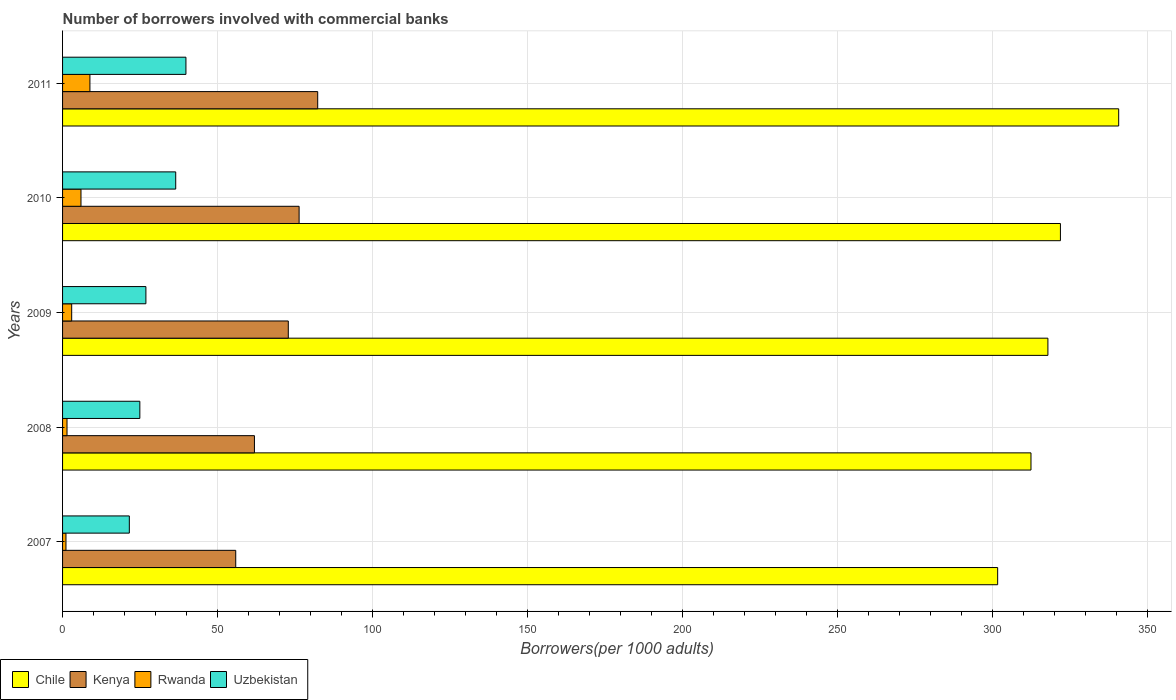How many different coloured bars are there?
Make the answer very short. 4. How many groups of bars are there?
Provide a short and direct response. 5. Are the number of bars on each tick of the Y-axis equal?
Your response must be concise. Yes. What is the number of borrowers involved with commercial banks in Chile in 2008?
Make the answer very short. 312.53. Across all years, what is the maximum number of borrowers involved with commercial banks in Uzbekistan?
Your response must be concise. 39.81. Across all years, what is the minimum number of borrowers involved with commercial banks in Uzbekistan?
Provide a succinct answer. 21.54. In which year was the number of borrowers involved with commercial banks in Kenya maximum?
Offer a terse response. 2011. What is the total number of borrowers involved with commercial banks in Uzbekistan in the graph?
Provide a succinct answer. 149.71. What is the difference between the number of borrowers involved with commercial banks in Kenya in 2010 and that in 2011?
Your answer should be compact. -6. What is the difference between the number of borrowers involved with commercial banks in Uzbekistan in 2010 and the number of borrowers involved with commercial banks in Chile in 2011?
Offer a very short reply. -304.32. What is the average number of borrowers involved with commercial banks in Rwanda per year?
Offer a very short reply. 4.05. In the year 2007, what is the difference between the number of borrowers involved with commercial banks in Kenya and number of borrowers involved with commercial banks in Chile?
Provide a short and direct response. -245.89. What is the ratio of the number of borrowers involved with commercial banks in Kenya in 2010 to that in 2011?
Provide a short and direct response. 0.93. Is the number of borrowers involved with commercial banks in Kenya in 2007 less than that in 2010?
Your answer should be compact. Yes. What is the difference between the highest and the second highest number of borrowers involved with commercial banks in Uzbekistan?
Make the answer very short. 3.3. What is the difference between the highest and the lowest number of borrowers involved with commercial banks in Chile?
Ensure brevity in your answer.  39.06. In how many years, is the number of borrowers involved with commercial banks in Uzbekistan greater than the average number of borrowers involved with commercial banks in Uzbekistan taken over all years?
Your response must be concise. 2. Is it the case that in every year, the sum of the number of borrowers involved with commercial banks in Chile and number of borrowers involved with commercial banks in Kenya is greater than the sum of number of borrowers involved with commercial banks in Uzbekistan and number of borrowers involved with commercial banks in Rwanda?
Make the answer very short. No. What does the 2nd bar from the top in 2010 represents?
Offer a very short reply. Rwanda. What does the 2nd bar from the bottom in 2009 represents?
Offer a terse response. Kenya. Is it the case that in every year, the sum of the number of borrowers involved with commercial banks in Rwanda and number of borrowers involved with commercial banks in Kenya is greater than the number of borrowers involved with commercial banks in Uzbekistan?
Give a very brief answer. Yes. How many years are there in the graph?
Make the answer very short. 5. Are the values on the major ticks of X-axis written in scientific E-notation?
Provide a short and direct response. No. Does the graph contain any zero values?
Your response must be concise. No. Does the graph contain grids?
Keep it short and to the point. Yes. Where does the legend appear in the graph?
Offer a terse response. Bottom left. How are the legend labels stacked?
Your answer should be very brief. Horizontal. What is the title of the graph?
Provide a succinct answer. Number of borrowers involved with commercial banks. Does "Mali" appear as one of the legend labels in the graph?
Your answer should be compact. No. What is the label or title of the X-axis?
Your response must be concise. Borrowers(per 1000 adults). What is the label or title of the Y-axis?
Ensure brevity in your answer.  Years. What is the Borrowers(per 1000 adults) in Chile in 2007?
Make the answer very short. 301.77. What is the Borrowers(per 1000 adults) of Kenya in 2007?
Ensure brevity in your answer.  55.89. What is the Borrowers(per 1000 adults) in Rwanda in 2007?
Keep it short and to the point. 1.1. What is the Borrowers(per 1000 adults) of Uzbekistan in 2007?
Your response must be concise. 21.54. What is the Borrowers(per 1000 adults) of Chile in 2008?
Give a very brief answer. 312.53. What is the Borrowers(per 1000 adults) of Kenya in 2008?
Your answer should be compact. 61.92. What is the Borrowers(per 1000 adults) in Rwanda in 2008?
Provide a succinct answer. 1.44. What is the Borrowers(per 1000 adults) in Uzbekistan in 2008?
Your response must be concise. 24.94. What is the Borrowers(per 1000 adults) of Chile in 2009?
Your answer should be compact. 317.99. What is the Borrowers(per 1000 adults) in Kenya in 2009?
Offer a very short reply. 72.85. What is the Borrowers(per 1000 adults) of Rwanda in 2009?
Make the answer very short. 2.94. What is the Borrowers(per 1000 adults) of Uzbekistan in 2009?
Keep it short and to the point. 26.9. What is the Borrowers(per 1000 adults) of Chile in 2010?
Give a very brief answer. 322.03. What is the Borrowers(per 1000 adults) of Kenya in 2010?
Provide a succinct answer. 76.34. What is the Borrowers(per 1000 adults) in Rwanda in 2010?
Offer a terse response. 5.94. What is the Borrowers(per 1000 adults) of Uzbekistan in 2010?
Your answer should be compact. 36.52. What is the Borrowers(per 1000 adults) in Chile in 2011?
Provide a succinct answer. 340.83. What is the Borrowers(per 1000 adults) in Kenya in 2011?
Your response must be concise. 82.34. What is the Borrowers(per 1000 adults) in Rwanda in 2011?
Provide a succinct answer. 8.83. What is the Borrowers(per 1000 adults) of Uzbekistan in 2011?
Provide a succinct answer. 39.81. Across all years, what is the maximum Borrowers(per 1000 adults) in Chile?
Offer a very short reply. 340.83. Across all years, what is the maximum Borrowers(per 1000 adults) in Kenya?
Your answer should be very brief. 82.34. Across all years, what is the maximum Borrowers(per 1000 adults) of Rwanda?
Provide a succinct answer. 8.83. Across all years, what is the maximum Borrowers(per 1000 adults) in Uzbekistan?
Your answer should be compact. 39.81. Across all years, what is the minimum Borrowers(per 1000 adults) in Chile?
Provide a succinct answer. 301.77. Across all years, what is the minimum Borrowers(per 1000 adults) of Kenya?
Make the answer very short. 55.89. Across all years, what is the minimum Borrowers(per 1000 adults) of Rwanda?
Your answer should be very brief. 1.1. Across all years, what is the minimum Borrowers(per 1000 adults) of Uzbekistan?
Make the answer very short. 21.54. What is the total Borrowers(per 1000 adults) in Chile in the graph?
Provide a short and direct response. 1595.16. What is the total Borrowers(per 1000 adults) in Kenya in the graph?
Offer a terse response. 349.34. What is the total Borrowers(per 1000 adults) of Rwanda in the graph?
Make the answer very short. 20.25. What is the total Borrowers(per 1000 adults) of Uzbekistan in the graph?
Your answer should be very brief. 149.71. What is the difference between the Borrowers(per 1000 adults) of Chile in 2007 and that in 2008?
Your answer should be compact. -10.76. What is the difference between the Borrowers(per 1000 adults) of Kenya in 2007 and that in 2008?
Keep it short and to the point. -6.04. What is the difference between the Borrowers(per 1000 adults) in Rwanda in 2007 and that in 2008?
Offer a very short reply. -0.34. What is the difference between the Borrowers(per 1000 adults) of Uzbekistan in 2007 and that in 2008?
Ensure brevity in your answer.  -3.4. What is the difference between the Borrowers(per 1000 adults) of Chile in 2007 and that in 2009?
Make the answer very short. -16.22. What is the difference between the Borrowers(per 1000 adults) of Kenya in 2007 and that in 2009?
Your answer should be compact. -16.96. What is the difference between the Borrowers(per 1000 adults) in Rwanda in 2007 and that in 2009?
Keep it short and to the point. -1.85. What is the difference between the Borrowers(per 1000 adults) of Uzbekistan in 2007 and that in 2009?
Offer a very short reply. -5.35. What is the difference between the Borrowers(per 1000 adults) in Chile in 2007 and that in 2010?
Your response must be concise. -20.26. What is the difference between the Borrowers(per 1000 adults) in Kenya in 2007 and that in 2010?
Your answer should be compact. -20.45. What is the difference between the Borrowers(per 1000 adults) of Rwanda in 2007 and that in 2010?
Your response must be concise. -4.85. What is the difference between the Borrowers(per 1000 adults) in Uzbekistan in 2007 and that in 2010?
Keep it short and to the point. -14.97. What is the difference between the Borrowers(per 1000 adults) of Chile in 2007 and that in 2011?
Make the answer very short. -39.06. What is the difference between the Borrowers(per 1000 adults) in Kenya in 2007 and that in 2011?
Your response must be concise. -26.45. What is the difference between the Borrowers(per 1000 adults) of Rwanda in 2007 and that in 2011?
Give a very brief answer. -7.73. What is the difference between the Borrowers(per 1000 adults) in Uzbekistan in 2007 and that in 2011?
Keep it short and to the point. -18.27. What is the difference between the Borrowers(per 1000 adults) in Chile in 2008 and that in 2009?
Your answer should be very brief. -5.46. What is the difference between the Borrowers(per 1000 adults) of Kenya in 2008 and that in 2009?
Make the answer very short. -10.93. What is the difference between the Borrowers(per 1000 adults) in Rwanda in 2008 and that in 2009?
Your response must be concise. -1.51. What is the difference between the Borrowers(per 1000 adults) of Uzbekistan in 2008 and that in 2009?
Your response must be concise. -1.96. What is the difference between the Borrowers(per 1000 adults) of Chile in 2008 and that in 2010?
Keep it short and to the point. -9.5. What is the difference between the Borrowers(per 1000 adults) of Kenya in 2008 and that in 2010?
Provide a short and direct response. -14.42. What is the difference between the Borrowers(per 1000 adults) of Rwanda in 2008 and that in 2010?
Ensure brevity in your answer.  -4.51. What is the difference between the Borrowers(per 1000 adults) in Uzbekistan in 2008 and that in 2010?
Provide a short and direct response. -11.57. What is the difference between the Borrowers(per 1000 adults) of Chile in 2008 and that in 2011?
Offer a very short reply. -28.3. What is the difference between the Borrowers(per 1000 adults) of Kenya in 2008 and that in 2011?
Your response must be concise. -20.41. What is the difference between the Borrowers(per 1000 adults) in Rwanda in 2008 and that in 2011?
Provide a succinct answer. -7.39. What is the difference between the Borrowers(per 1000 adults) of Uzbekistan in 2008 and that in 2011?
Offer a very short reply. -14.87. What is the difference between the Borrowers(per 1000 adults) of Chile in 2009 and that in 2010?
Offer a very short reply. -4.04. What is the difference between the Borrowers(per 1000 adults) of Kenya in 2009 and that in 2010?
Offer a terse response. -3.49. What is the difference between the Borrowers(per 1000 adults) in Rwanda in 2009 and that in 2010?
Your answer should be compact. -3. What is the difference between the Borrowers(per 1000 adults) in Uzbekistan in 2009 and that in 2010?
Your answer should be very brief. -9.62. What is the difference between the Borrowers(per 1000 adults) of Chile in 2009 and that in 2011?
Provide a succinct answer. -22.84. What is the difference between the Borrowers(per 1000 adults) of Kenya in 2009 and that in 2011?
Your answer should be compact. -9.49. What is the difference between the Borrowers(per 1000 adults) in Rwanda in 2009 and that in 2011?
Provide a succinct answer. -5.89. What is the difference between the Borrowers(per 1000 adults) of Uzbekistan in 2009 and that in 2011?
Provide a short and direct response. -12.92. What is the difference between the Borrowers(per 1000 adults) in Chile in 2010 and that in 2011?
Your answer should be compact. -18.8. What is the difference between the Borrowers(per 1000 adults) of Kenya in 2010 and that in 2011?
Give a very brief answer. -6. What is the difference between the Borrowers(per 1000 adults) in Rwanda in 2010 and that in 2011?
Provide a short and direct response. -2.89. What is the difference between the Borrowers(per 1000 adults) of Uzbekistan in 2010 and that in 2011?
Offer a terse response. -3.3. What is the difference between the Borrowers(per 1000 adults) of Chile in 2007 and the Borrowers(per 1000 adults) of Kenya in 2008?
Give a very brief answer. 239.85. What is the difference between the Borrowers(per 1000 adults) in Chile in 2007 and the Borrowers(per 1000 adults) in Rwanda in 2008?
Give a very brief answer. 300.34. What is the difference between the Borrowers(per 1000 adults) in Chile in 2007 and the Borrowers(per 1000 adults) in Uzbekistan in 2008?
Your answer should be very brief. 276.83. What is the difference between the Borrowers(per 1000 adults) of Kenya in 2007 and the Borrowers(per 1000 adults) of Rwanda in 2008?
Provide a succinct answer. 54.45. What is the difference between the Borrowers(per 1000 adults) in Kenya in 2007 and the Borrowers(per 1000 adults) in Uzbekistan in 2008?
Make the answer very short. 30.95. What is the difference between the Borrowers(per 1000 adults) in Rwanda in 2007 and the Borrowers(per 1000 adults) in Uzbekistan in 2008?
Provide a succinct answer. -23.84. What is the difference between the Borrowers(per 1000 adults) in Chile in 2007 and the Borrowers(per 1000 adults) in Kenya in 2009?
Offer a very short reply. 228.92. What is the difference between the Borrowers(per 1000 adults) of Chile in 2007 and the Borrowers(per 1000 adults) of Rwanda in 2009?
Offer a terse response. 298.83. What is the difference between the Borrowers(per 1000 adults) of Chile in 2007 and the Borrowers(per 1000 adults) of Uzbekistan in 2009?
Offer a terse response. 274.88. What is the difference between the Borrowers(per 1000 adults) of Kenya in 2007 and the Borrowers(per 1000 adults) of Rwanda in 2009?
Your answer should be compact. 52.94. What is the difference between the Borrowers(per 1000 adults) in Kenya in 2007 and the Borrowers(per 1000 adults) in Uzbekistan in 2009?
Provide a short and direct response. 28.99. What is the difference between the Borrowers(per 1000 adults) of Rwanda in 2007 and the Borrowers(per 1000 adults) of Uzbekistan in 2009?
Offer a very short reply. -25.8. What is the difference between the Borrowers(per 1000 adults) in Chile in 2007 and the Borrowers(per 1000 adults) in Kenya in 2010?
Provide a succinct answer. 225.43. What is the difference between the Borrowers(per 1000 adults) of Chile in 2007 and the Borrowers(per 1000 adults) of Rwanda in 2010?
Your answer should be very brief. 295.83. What is the difference between the Borrowers(per 1000 adults) in Chile in 2007 and the Borrowers(per 1000 adults) in Uzbekistan in 2010?
Your answer should be very brief. 265.26. What is the difference between the Borrowers(per 1000 adults) of Kenya in 2007 and the Borrowers(per 1000 adults) of Rwanda in 2010?
Offer a terse response. 49.94. What is the difference between the Borrowers(per 1000 adults) of Kenya in 2007 and the Borrowers(per 1000 adults) of Uzbekistan in 2010?
Offer a terse response. 19.37. What is the difference between the Borrowers(per 1000 adults) in Rwanda in 2007 and the Borrowers(per 1000 adults) in Uzbekistan in 2010?
Give a very brief answer. -35.42. What is the difference between the Borrowers(per 1000 adults) in Chile in 2007 and the Borrowers(per 1000 adults) in Kenya in 2011?
Offer a terse response. 219.43. What is the difference between the Borrowers(per 1000 adults) in Chile in 2007 and the Borrowers(per 1000 adults) in Rwanda in 2011?
Keep it short and to the point. 292.94. What is the difference between the Borrowers(per 1000 adults) in Chile in 2007 and the Borrowers(per 1000 adults) in Uzbekistan in 2011?
Give a very brief answer. 261.96. What is the difference between the Borrowers(per 1000 adults) of Kenya in 2007 and the Borrowers(per 1000 adults) of Rwanda in 2011?
Your answer should be very brief. 47.06. What is the difference between the Borrowers(per 1000 adults) in Kenya in 2007 and the Borrowers(per 1000 adults) in Uzbekistan in 2011?
Offer a terse response. 16.07. What is the difference between the Borrowers(per 1000 adults) in Rwanda in 2007 and the Borrowers(per 1000 adults) in Uzbekistan in 2011?
Your response must be concise. -38.72. What is the difference between the Borrowers(per 1000 adults) of Chile in 2008 and the Borrowers(per 1000 adults) of Kenya in 2009?
Give a very brief answer. 239.68. What is the difference between the Borrowers(per 1000 adults) of Chile in 2008 and the Borrowers(per 1000 adults) of Rwanda in 2009?
Offer a very short reply. 309.59. What is the difference between the Borrowers(per 1000 adults) in Chile in 2008 and the Borrowers(per 1000 adults) in Uzbekistan in 2009?
Provide a succinct answer. 285.64. What is the difference between the Borrowers(per 1000 adults) of Kenya in 2008 and the Borrowers(per 1000 adults) of Rwanda in 2009?
Offer a terse response. 58.98. What is the difference between the Borrowers(per 1000 adults) in Kenya in 2008 and the Borrowers(per 1000 adults) in Uzbekistan in 2009?
Offer a terse response. 35.03. What is the difference between the Borrowers(per 1000 adults) of Rwanda in 2008 and the Borrowers(per 1000 adults) of Uzbekistan in 2009?
Your answer should be very brief. -25.46. What is the difference between the Borrowers(per 1000 adults) in Chile in 2008 and the Borrowers(per 1000 adults) in Kenya in 2010?
Your answer should be very brief. 236.19. What is the difference between the Borrowers(per 1000 adults) of Chile in 2008 and the Borrowers(per 1000 adults) of Rwanda in 2010?
Ensure brevity in your answer.  306.59. What is the difference between the Borrowers(per 1000 adults) of Chile in 2008 and the Borrowers(per 1000 adults) of Uzbekistan in 2010?
Provide a short and direct response. 276.02. What is the difference between the Borrowers(per 1000 adults) of Kenya in 2008 and the Borrowers(per 1000 adults) of Rwanda in 2010?
Provide a short and direct response. 55.98. What is the difference between the Borrowers(per 1000 adults) in Kenya in 2008 and the Borrowers(per 1000 adults) in Uzbekistan in 2010?
Provide a succinct answer. 25.41. What is the difference between the Borrowers(per 1000 adults) of Rwanda in 2008 and the Borrowers(per 1000 adults) of Uzbekistan in 2010?
Keep it short and to the point. -35.08. What is the difference between the Borrowers(per 1000 adults) of Chile in 2008 and the Borrowers(per 1000 adults) of Kenya in 2011?
Offer a very short reply. 230.19. What is the difference between the Borrowers(per 1000 adults) of Chile in 2008 and the Borrowers(per 1000 adults) of Rwanda in 2011?
Your response must be concise. 303.7. What is the difference between the Borrowers(per 1000 adults) of Chile in 2008 and the Borrowers(per 1000 adults) of Uzbekistan in 2011?
Provide a short and direct response. 272.72. What is the difference between the Borrowers(per 1000 adults) of Kenya in 2008 and the Borrowers(per 1000 adults) of Rwanda in 2011?
Provide a short and direct response. 53.09. What is the difference between the Borrowers(per 1000 adults) in Kenya in 2008 and the Borrowers(per 1000 adults) in Uzbekistan in 2011?
Your answer should be compact. 22.11. What is the difference between the Borrowers(per 1000 adults) of Rwanda in 2008 and the Borrowers(per 1000 adults) of Uzbekistan in 2011?
Offer a very short reply. -38.38. What is the difference between the Borrowers(per 1000 adults) of Chile in 2009 and the Borrowers(per 1000 adults) of Kenya in 2010?
Your answer should be very brief. 241.65. What is the difference between the Borrowers(per 1000 adults) in Chile in 2009 and the Borrowers(per 1000 adults) in Rwanda in 2010?
Make the answer very short. 312.05. What is the difference between the Borrowers(per 1000 adults) in Chile in 2009 and the Borrowers(per 1000 adults) in Uzbekistan in 2010?
Give a very brief answer. 281.48. What is the difference between the Borrowers(per 1000 adults) in Kenya in 2009 and the Borrowers(per 1000 adults) in Rwanda in 2010?
Provide a short and direct response. 66.9. What is the difference between the Borrowers(per 1000 adults) in Kenya in 2009 and the Borrowers(per 1000 adults) in Uzbekistan in 2010?
Offer a terse response. 36.33. What is the difference between the Borrowers(per 1000 adults) in Rwanda in 2009 and the Borrowers(per 1000 adults) in Uzbekistan in 2010?
Provide a succinct answer. -33.57. What is the difference between the Borrowers(per 1000 adults) in Chile in 2009 and the Borrowers(per 1000 adults) in Kenya in 2011?
Your answer should be compact. 235.65. What is the difference between the Borrowers(per 1000 adults) in Chile in 2009 and the Borrowers(per 1000 adults) in Rwanda in 2011?
Provide a short and direct response. 309.16. What is the difference between the Borrowers(per 1000 adults) in Chile in 2009 and the Borrowers(per 1000 adults) in Uzbekistan in 2011?
Keep it short and to the point. 278.18. What is the difference between the Borrowers(per 1000 adults) of Kenya in 2009 and the Borrowers(per 1000 adults) of Rwanda in 2011?
Provide a short and direct response. 64.02. What is the difference between the Borrowers(per 1000 adults) in Kenya in 2009 and the Borrowers(per 1000 adults) in Uzbekistan in 2011?
Make the answer very short. 33.03. What is the difference between the Borrowers(per 1000 adults) in Rwanda in 2009 and the Borrowers(per 1000 adults) in Uzbekistan in 2011?
Ensure brevity in your answer.  -36.87. What is the difference between the Borrowers(per 1000 adults) of Chile in 2010 and the Borrowers(per 1000 adults) of Kenya in 2011?
Make the answer very short. 239.69. What is the difference between the Borrowers(per 1000 adults) in Chile in 2010 and the Borrowers(per 1000 adults) in Rwanda in 2011?
Ensure brevity in your answer.  313.2. What is the difference between the Borrowers(per 1000 adults) in Chile in 2010 and the Borrowers(per 1000 adults) in Uzbekistan in 2011?
Your response must be concise. 282.22. What is the difference between the Borrowers(per 1000 adults) in Kenya in 2010 and the Borrowers(per 1000 adults) in Rwanda in 2011?
Provide a succinct answer. 67.51. What is the difference between the Borrowers(per 1000 adults) of Kenya in 2010 and the Borrowers(per 1000 adults) of Uzbekistan in 2011?
Offer a very short reply. 36.53. What is the difference between the Borrowers(per 1000 adults) of Rwanda in 2010 and the Borrowers(per 1000 adults) of Uzbekistan in 2011?
Provide a short and direct response. -33.87. What is the average Borrowers(per 1000 adults) of Chile per year?
Your response must be concise. 319.03. What is the average Borrowers(per 1000 adults) of Kenya per year?
Your response must be concise. 69.87. What is the average Borrowers(per 1000 adults) in Rwanda per year?
Your answer should be compact. 4.05. What is the average Borrowers(per 1000 adults) in Uzbekistan per year?
Give a very brief answer. 29.94. In the year 2007, what is the difference between the Borrowers(per 1000 adults) of Chile and Borrowers(per 1000 adults) of Kenya?
Your answer should be very brief. 245.89. In the year 2007, what is the difference between the Borrowers(per 1000 adults) in Chile and Borrowers(per 1000 adults) in Rwanda?
Your answer should be compact. 300.68. In the year 2007, what is the difference between the Borrowers(per 1000 adults) of Chile and Borrowers(per 1000 adults) of Uzbekistan?
Give a very brief answer. 280.23. In the year 2007, what is the difference between the Borrowers(per 1000 adults) in Kenya and Borrowers(per 1000 adults) in Rwanda?
Provide a short and direct response. 54.79. In the year 2007, what is the difference between the Borrowers(per 1000 adults) in Kenya and Borrowers(per 1000 adults) in Uzbekistan?
Your response must be concise. 34.34. In the year 2007, what is the difference between the Borrowers(per 1000 adults) of Rwanda and Borrowers(per 1000 adults) of Uzbekistan?
Offer a very short reply. -20.45. In the year 2008, what is the difference between the Borrowers(per 1000 adults) of Chile and Borrowers(per 1000 adults) of Kenya?
Provide a short and direct response. 250.61. In the year 2008, what is the difference between the Borrowers(per 1000 adults) of Chile and Borrowers(per 1000 adults) of Rwanda?
Your answer should be very brief. 311.1. In the year 2008, what is the difference between the Borrowers(per 1000 adults) in Chile and Borrowers(per 1000 adults) in Uzbekistan?
Provide a succinct answer. 287.59. In the year 2008, what is the difference between the Borrowers(per 1000 adults) in Kenya and Borrowers(per 1000 adults) in Rwanda?
Provide a short and direct response. 60.49. In the year 2008, what is the difference between the Borrowers(per 1000 adults) of Kenya and Borrowers(per 1000 adults) of Uzbekistan?
Make the answer very short. 36.98. In the year 2008, what is the difference between the Borrowers(per 1000 adults) in Rwanda and Borrowers(per 1000 adults) in Uzbekistan?
Your response must be concise. -23.51. In the year 2009, what is the difference between the Borrowers(per 1000 adults) in Chile and Borrowers(per 1000 adults) in Kenya?
Give a very brief answer. 245.14. In the year 2009, what is the difference between the Borrowers(per 1000 adults) in Chile and Borrowers(per 1000 adults) in Rwanda?
Your answer should be compact. 315.05. In the year 2009, what is the difference between the Borrowers(per 1000 adults) of Chile and Borrowers(per 1000 adults) of Uzbekistan?
Provide a short and direct response. 291.09. In the year 2009, what is the difference between the Borrowers(per 1000 adults) of Kenya and Borrowers(per 1000 adults) of Rwanda?
Give a very brief answer. 69.9. In the year 2009, what is the difference between the Borrowers(per 1000 adults) in Kenya and Borrowers(per 1000 adults) in Uzbekistan?
Keep it short and to the point. 45.95. In the year 2009, what is the difference between the Borrowers(per 1000 adults) in Rwanda and Borrowers(per 1000 adults) in Uzbekistan?
Make the answer very short. -23.95. In the year 2010, what is the difference between the Borrowers(per 1000 adults) in Chile and Borrowers(per 1000 adults) in Kenya?
Your answer should be very brief. 245.69. In the year 2010, what is the difference between the Borrowers(per 1000 adults) of Chile and Borrowers(per 1000 adults) of Rwanda?
Make the answer very short. 316.09. In the year 2010, what is the difference between the Borrowers(per 1000 adults) in Chile and Borrowers(per 1000 adults) in Uzbekistan?
Offer a terse response. 285.52. In the year 2010, what is the difference between the Borrowers(per 1000 adults) in Kenya and Borrowers(per 1000 adults) in Rwanda?
Your answer should be compact. 70.4. In the year 2010, what is the difference between the Borrowers(per 1000 adults) of Kenya and Borrowers(per 1000 adults) of Uzbekistan?
Offer a terse response. 39.82. In the year 2010, what is the difference between the Borrowers(per 1000 adults) in Rwanda and Borrowers(per 1000 adults) in Uzbekistan?
Provide a succinct answer. -30.57. In the year 2011, what is the difference between the Borrowers(per 1000 adults) of Chile and Borrowers(per 1000 adults) of Kenya?
Offer a very short reply. 258.5. In the year 2011, what is the difference between the Borrowers(per 1000 adults) in Chile and Borrowers(per 1000 adults) in Rwanda?
Ensure brevity in your answer.  332. In the year 2011, what is the difference between the Borrowers(per 1000 adults) in Chile and Borrowers(per 1000 adults) in Uzbekistan?
Your answer should be compact. 301.02. In the year 2011, what is the difference between the Borrowers(per 1000 adults) of Kenya and Borrowers(per 1000 adults) of Rwanda?
Make the answer very short. 73.51. In the year 2011, what is the difference between the Borrowers(per 1000 adults) of Kenya and Borrowers(per 1000 adults) of Uzbekistan?
Keep it short and to the point. 42.52. In the year 2011, what is the difference between the Borrowers(per 1000 adults) in Rwanda and Borrowers(per 1000 adults) in Uzbekistan?
Give a very brief answer. -30.98. What is the ratio of the Borrowers(per 1000 adults) in Chile in 2007 to that in 2008?
Make the answer very short. 0.97. What is the ratio of the Borrowers(per 1000 adults) of Kenya in 2007 to that in 2008?
Your answer should be very brief. 0.9. What is the ratio of the Borrowers(per 1000 adults) in Rwanda in 2007 to that in 2008?
Your response must be concise. 0.76. What is the ratio of the Borrowers(per 1000 adults) of Uzbekistan in 2007 to that in 2008?
Your response must be concise. 0.86. What is the ratio of the Borrowers(per 1000 adults) in Chile in 2007 to that in 2009?
Offer a very short reply. 0.95. What is the ratio of the Borrowers(per 1000 adults) in Kenya in 2007 to that in 2009?
Ensure brevity in your answer.  0.77. What is the ratio of the Borrowers(per 1000 adults) of Rwanda in 2007 to that in 2009?
Provide a succinct answer. 0.37. What is the ratio of the Borrowers(per 1000 adults) of Uzbekistan in 2007 to that in 2009?
Provide a succinct answer. 0.8. What is the ratio of the Borrowers(per 1000 adults) of Chile in 2007 to that in 2010?
Ensure brevity in your answer.  0.94. What is the ratio of the Borrowers(per 1000 adults) of Kenya in 2007 to that in 2010?
Make the answer very short. 0.73. What is the ratio of the Borrowers(per 1000 adults) of Rwanda in 2007 to that in 2010?
Keep it short and to the point. 0.18. What is the ratio of the Borrowers(per 1000 adults) in Uzbekistan in 2007 to that in 2010?
Your response must be concise. 0.59. What is the ratio of the Borrowers(per 1000 adults) of Chile in 2007 to that in 2011?
Provide a short and direct response. 0.89. What is the ratio of the Borrowers(per 1000 adults) in Kenya in 2007 to that in 2011?
Your response must be concise. 0.68. What is the ratio of the Borrowers(per 1000 adults) of Rwanda in 2007 to that in 2011?
Provide a succinct answer. 0.12. What is the ratio of the Borrowers(per 1000 adults) of Uzbekistan in 2007 to that in 2011?
Your answer should be very brief. 0.54. What is the ratio of the Borrowers(per 1000 adults) of Chile in 2008 to that in 2009?
Your answer should be very brief. 0.98. What is the ratio of the Borrowers(per 1000 adults) of Kenya in 2008 to that in 2009?
Give a very brief answer. 0.85. What is the ratio of the Borrowers(per 1000 adults) of Rwanda in 2008 to that in 2009?
Make the answer very short. 0.49. What is the ratio of the Borrowers(per 1000 adults) of Uzbekistan in 2008 to that in 2009?
Ensure brevity in your answer.  0.93. What is the ratio of the Borrowers(per 1000 adults) in Chile in 2008 to that in 2010?
Provide a succinct answer. 0.97. What is the ratio of the Borrowers(per 1000 adults) in Kenya in 2008 to that in 2010?
Offer a terse response. 0.81. What is the ratio of the Borrowers(per 1000 adults) of Rwanda in 2008 to that in 2010?
Offer a very short reply. 0.24. What is the ratio of the Borrowers(per 1000 adults) in Uzbekistan in 2008 to that in 2010?
Provide a short and direct response. 0.68. What is the ratio of the Borrowers(per 1000 adults) of Chile in 2008 to that in 2011?
Your answer should be compact. 0.92. What is the ratio of the Borrowers(per 1000 adults) in Kenya in 2008 to that in 2011?
Offer a terse response. 0.75. What is the ratio of the Borrowers(per 1000 adults) in Rwanda in 2008 to that in 2011?
Your response must be concise. 0.16. What is the ratio of the Borrowers(per 1000 adults) of Uzbekistan in 2008 to that in 2011?
Your answer should be very brief. 0.63. What is the ratio of the Borrowers(per 1000 adults) in Chile in 2009 to that in 2010?
Your response must be concise. 0.99. What is the ratio of the Borrowers(per 1000 adults) in Kenya in 2009 to that in 2010?
Your response must be concise. 0.95. What is the ratio of the Borrowers(per 1000 adults) in Rwanda in 2009 to that in 2010?
Offer a very short reply. 0.5. What is the ratio of the Borrowers(per 1000 adults) in Uzbekistan in 2009 to that in 2010?
Ensure brevity in your answer.  0.74. What is the ratio of the Borrowers(per 1000 adults) of Chile in 2009 to that in 2011?
Make the answer very short. 0.93. What is the ratio of the Borrowers(per 1000 adults) in Kenya in 2009 to that in 2011?
Provide a succinct answer. 0.88. What is the ratio of the Borrowers(per 1000 adults) in Rwanda in 2009 to that in 2011?
Give a very brief answer. 0.33. What is the ratio of the Borrowers(per 1000 adults) of Uzbekistan in 2009 to that in 2011?
Keep it short and to the point. 0.68. What is the ratio of the Borrowers(per 1000 adults) of Chile in 2010 to that in 2011?
Ensure brevity in your answer.  0.94. What is the ratio of the Borrowers(per 1000 adults) of Kenya in 2010 to that in 2011?
Make the answer very short. 0.93. What is the ratio of the Borrowers(per 1000 adults) in Rwanda in 2010 to that in 2011?
Your answer should be very brief. 0.67. What is the ratio of the Borrowers(per 1000 adults) of Uzbekistan in 2010 to that in 2011?
Keep it short and to the point. 0.92. What is the difference between the highest and the second highest Borrowers(per 1000 adults) of Chile?
Offer a terse response. 18.8. What is the difference between the highest and the second highest Borrowers(per 1000 adults) in Kenya?
Offer a very short reply. 6. What is the difference between the highest and the second highest Borrowers(per 1000 adults) of Rwanda?
Your response must be concise. 2.89. What is the difference between the highest and the second highest Borrowers(per 1000 adults) of Uzbekistan?
Offer a very short reply. 3.3. What is the difference between the highest and the lowest Borrowers(per 1000 adults) of Chile?
Offer a very short reply. 39.06. What is the difference between the highest and the lowest Borrowers(per 1000 adults) of Kenya?
Give a very brief answer. 26.45. What is the difference between the highest and the lowest Borrowers(per 1000 adults) of Rwanda?
Offer a terse response. 7.73. What is the difference between the highest and the lowest Borrowers(per 1000 adults) in Uzbekistan?
Make the answer very short. 18.27. 